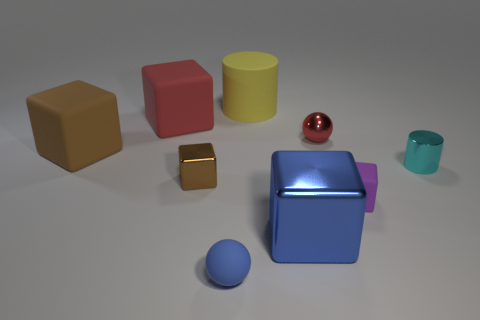What number of small rubber blocks have the same color as the large metal object?
Provide a succinct answer. 0. There is a large thing that is the same material as the red ball; what is its shape?
Provide a short and direct response. Cube. What is the size of the ball behind the small purple cube?
Ensure brevity in your answer.  Small. Are there an equal number of tiny blue spheres behind the large red thing and small red shiny objects to the right of the red metallic ball?
Make the answer very short. Yes. What color is the small block that is on the right side of the large block that is on the right side of the brown object in front of the brown matte thing?
Provide a short and direct response. Purple. How many tiny things are left of the purple thing and behind the big blue block?
Offer a very short reply. 2. Is the color of the small sphere in front of the tiny purple block the same as the small ball behind the purple object?
Your answer should be very brief. No. Is there anything else that has the same material as the large blue cube?
Your answer should be compact. Yes. What is the size of the brown metallic object that is the same shape as the small purple object?
Your answer should be very brief. Small. There is a blue matte object; are there any tiny metallic objects in front of it?
Offer a terse response. No. 